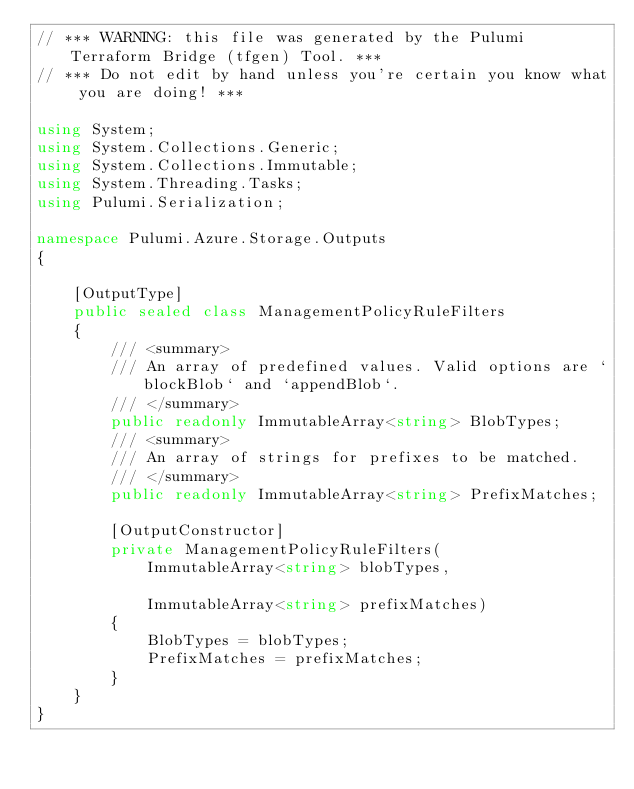<code> <loc_0><loc_0><loc_500><loc_500><_C#_>// *** WARNING: this file was generated by the Pulumi Terraform Bridge (tfgen) Tool. ***
// *** Do not edit by hand unless you're certain you know what you are doing! ***

using System;
using System.Collections.Generic;
using System.Collections.Immutable;
using System.Threading.Tasks;
using Pulumi.Serialization;

namespace Pulumi.Azure.Storage.Outputs
{

    [OutputType]
    public sealed class ManagementPolicyRuleFilters
    {
        /// <summary>
        /// An array of predefined values. Valid options are `blockBlob` and `appendBlob`.
        /// </summary>
        public readonly ImmutableArray<string> BlobTypes;
        /// <summary>
        /// An array of strings for prefixes to be matched.
        /// </summary>
        public readonly ImmutableArray<string> PrefixMatches;

        [OutputConstructor]
        private ManagementPolicyRuleFilters(
            ImmutableArray<string> blobTypes,

            ImmutableArray<string> prefixMatches)
        {
            BlobTypes = blobTypes;
            PrefixMatches = prefixMatches;
        }
    }
}
</code> 